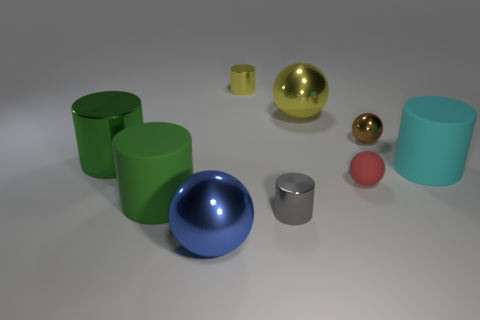There is a big thing that is the same color as the big shiny cylinder; what is it made of?
Your response must be concise. Rubber. The shiny thing that is both on the left side of the gray cylinder and in front of the small red matte sphere has what shape?
Your answer should be compact. Sphere. There is a tiny cylinder that is in front of the small shiny object that is on the left side of the gray shiny object; what is it made of?
Keep it short and to the point. Metal. Are there more green metal cylinders than tiny gray metal balls?
Ensure brevity in your answer.  Yes. Is the tiny matte sphere the same color as the tiny metallic ball?
Ensure brevity in your answer.  No. There is a cyan object that is the same size as the blue object; what is it made of?
Make the answer very short. Rubber. Are the big blue thing and the brown ball made of the same material?
Your answer should be very brief. Yes. What number of red balls are made of the same material as the big yellow sphere?
Your answer should be very brief. 0. What number of things are large metal things left of the yellow metallic sphere or small balls that are in front of the small brown metallic object?
Provide a succinct answer. 3. Are there more big metallic things that are behind the green rubber cylinder than red things right of the small rubber object?
Ensure brevity in your answer.  Yes. 